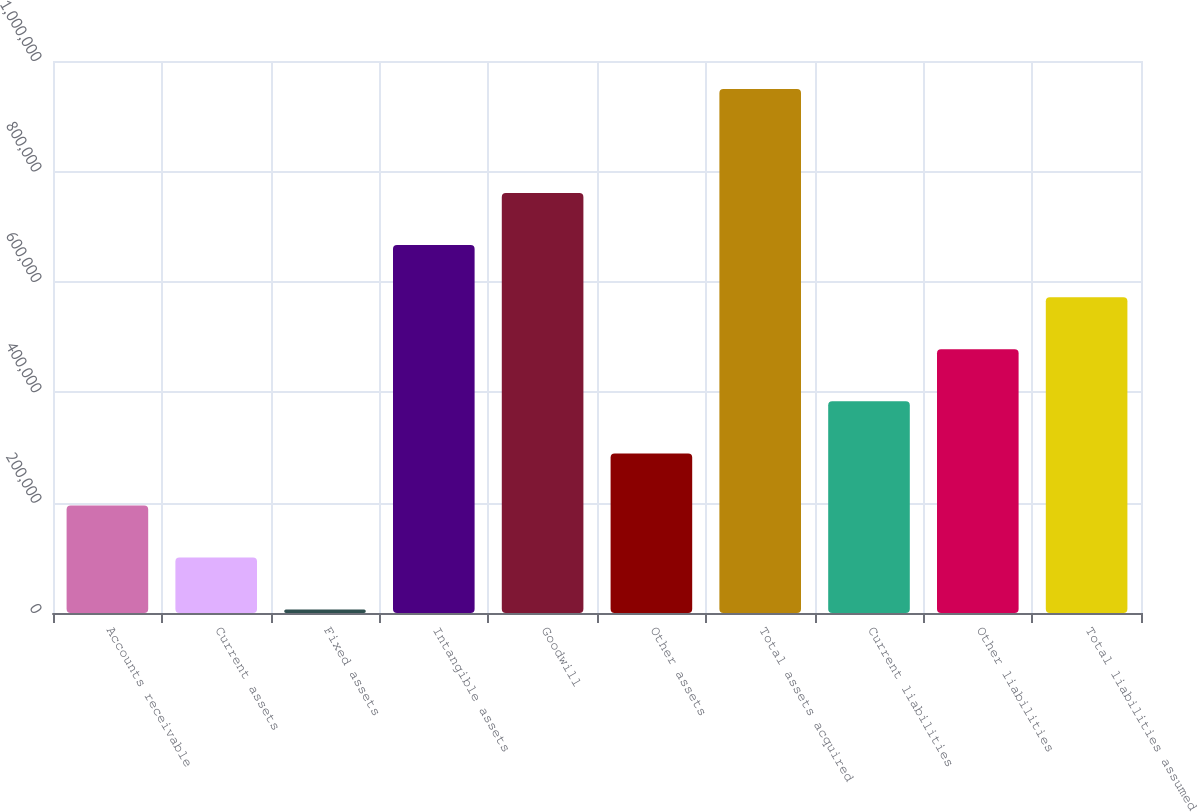Convert chart to OTSL. <chart><loc_0><loc_0><loc_500><loc_500><bar_chart><fcel>Accounts receivable<fcel>Current assets<fcel>Fixed assets<fcel>Intangible assets<fcel>Goodwill<fcel>Other assets<fcel>Total assets acquired<fcel>Current liabilities<fcel>Other liabilities<fcel>Total liabilities assumed<nl><fcel>194802<fcel>100474<fcel>6145<fcel>666446<fcel>760775<fcel>289131<fcel>949432<fcel>383460<fcel>477788<fcel>572117<nl></chart> 